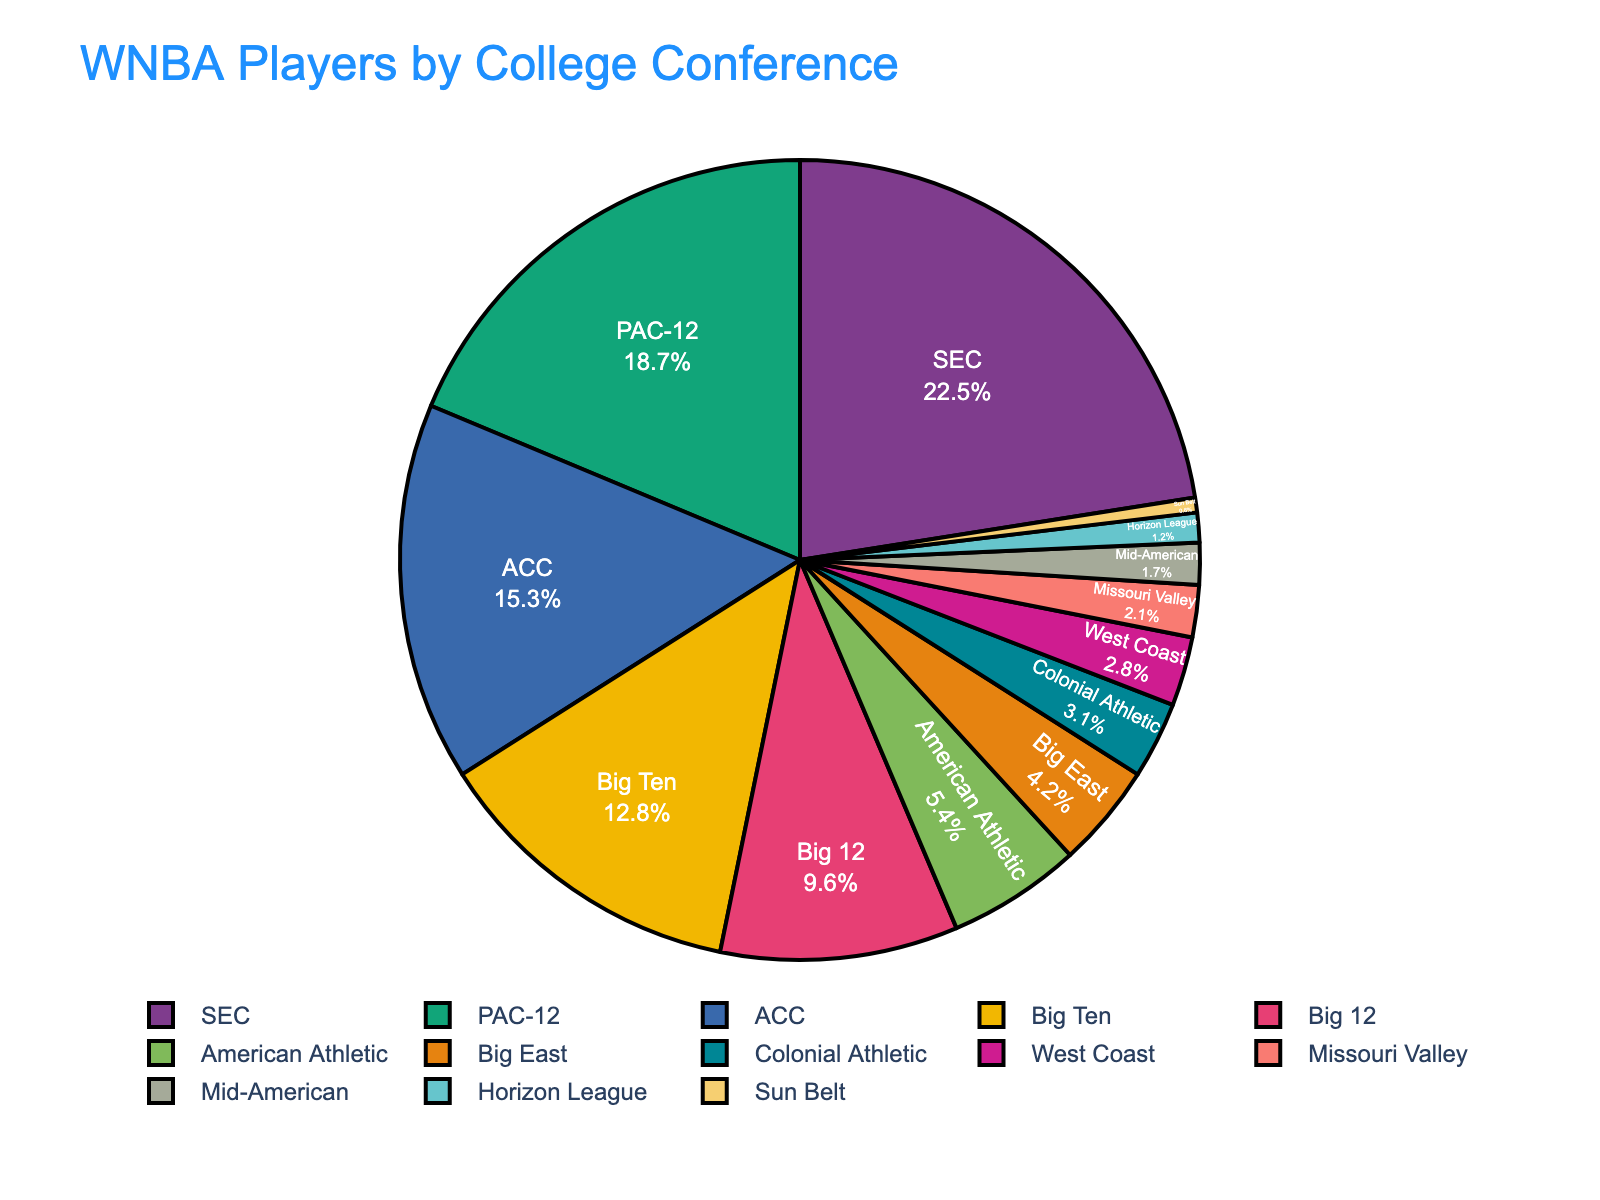Which conference has the highest percentage of WNBA players? To find the conference with the highest percentage, look at the largest slice of the pie chart. The SEC conference has the largest slice.
Answer: SEC Which college conference has a higher percentage of WNBA players, Big Ten or Big 12? Compare the slices representing Big Ten and Big 12. The Big Ten slice is larger than the Big 12 slice.
Answer: Big Ten What is the combined percentage of WNBA players from the SEC and the PAC-12? Add the percentages of SEC and PAC-12. SEC is 22.5% and PAC-12 is 18.7%. So, 22.5 + 18.7 = 41.2%.
Answer: 41.2% How many conferences have a percentage of WNBA players greater than 10%? Identify each slice of the pie chart that represents a conference with a percentage greater than 10%. These are SEC (22.5%), PAC-12 (18.7%), ACC (15.3%), and Big Ten (12.8%). This totals to 4 conferences.
Answer: 4 Which has a lower percentage of WNBA players, Colonial Athletic or Horizon League? Compare the slices for Colonial Athletic and Horizon League. The Horizon League slice is smaller than the Colonial Athletic slice.
Answer: Horizon League By how much is the percentage of WNBA players from the ACC higher than from the Big 12? Subtract the percentage of the Big 12 from the percentage of the ACC. ACC is 15.3% and Big 12 is 9.6%. So, 15.3 - 9.6 = 5.7%.
Answer: 5.7% What percentage of WNBA players come from conferences outside the top three listed (SEC, PAC-12, and ACC)? Sum the percentages of the top three conferences and subtract from 100%. SEC is 22.5%, PAC-12 is 18.7%, ACC is 15.3%. So, 22.5 + 18.7 + 15.3 = 56.5%. Then, 100 - 56.5 = 43.5%.
Answer: 43.5% Is the percentage of WNBA players from the Big 12 greater than the combined percentage of the Sun Belt and Horizon League? Compare the percentage of Big 12 to the combined percentage of Sun Belt and Horizon League. Big 12 is 9.6% and Sun Belt + Horizon League is 0.6% + 1.2% = 1.8%. 9.6% is greater than 1.8%.
Answer: Yes Are there more WNBA players from American Athletic than from Missouri Valley and West Coast combined? Compare the percentage of American Athletic to the sum of Missouri Valley and West Coast. American Athletic is 5.4% and Missouri Valley + West Coast is 2.1% + 2.8% = 4.9%. 5.4% is greater than 4.9%.
Answer: Yes 